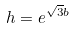<formula> <loc_0><loc_0><loc_500><loc_500>h = e ^ { \sqrt { 3 } b }</formula> 